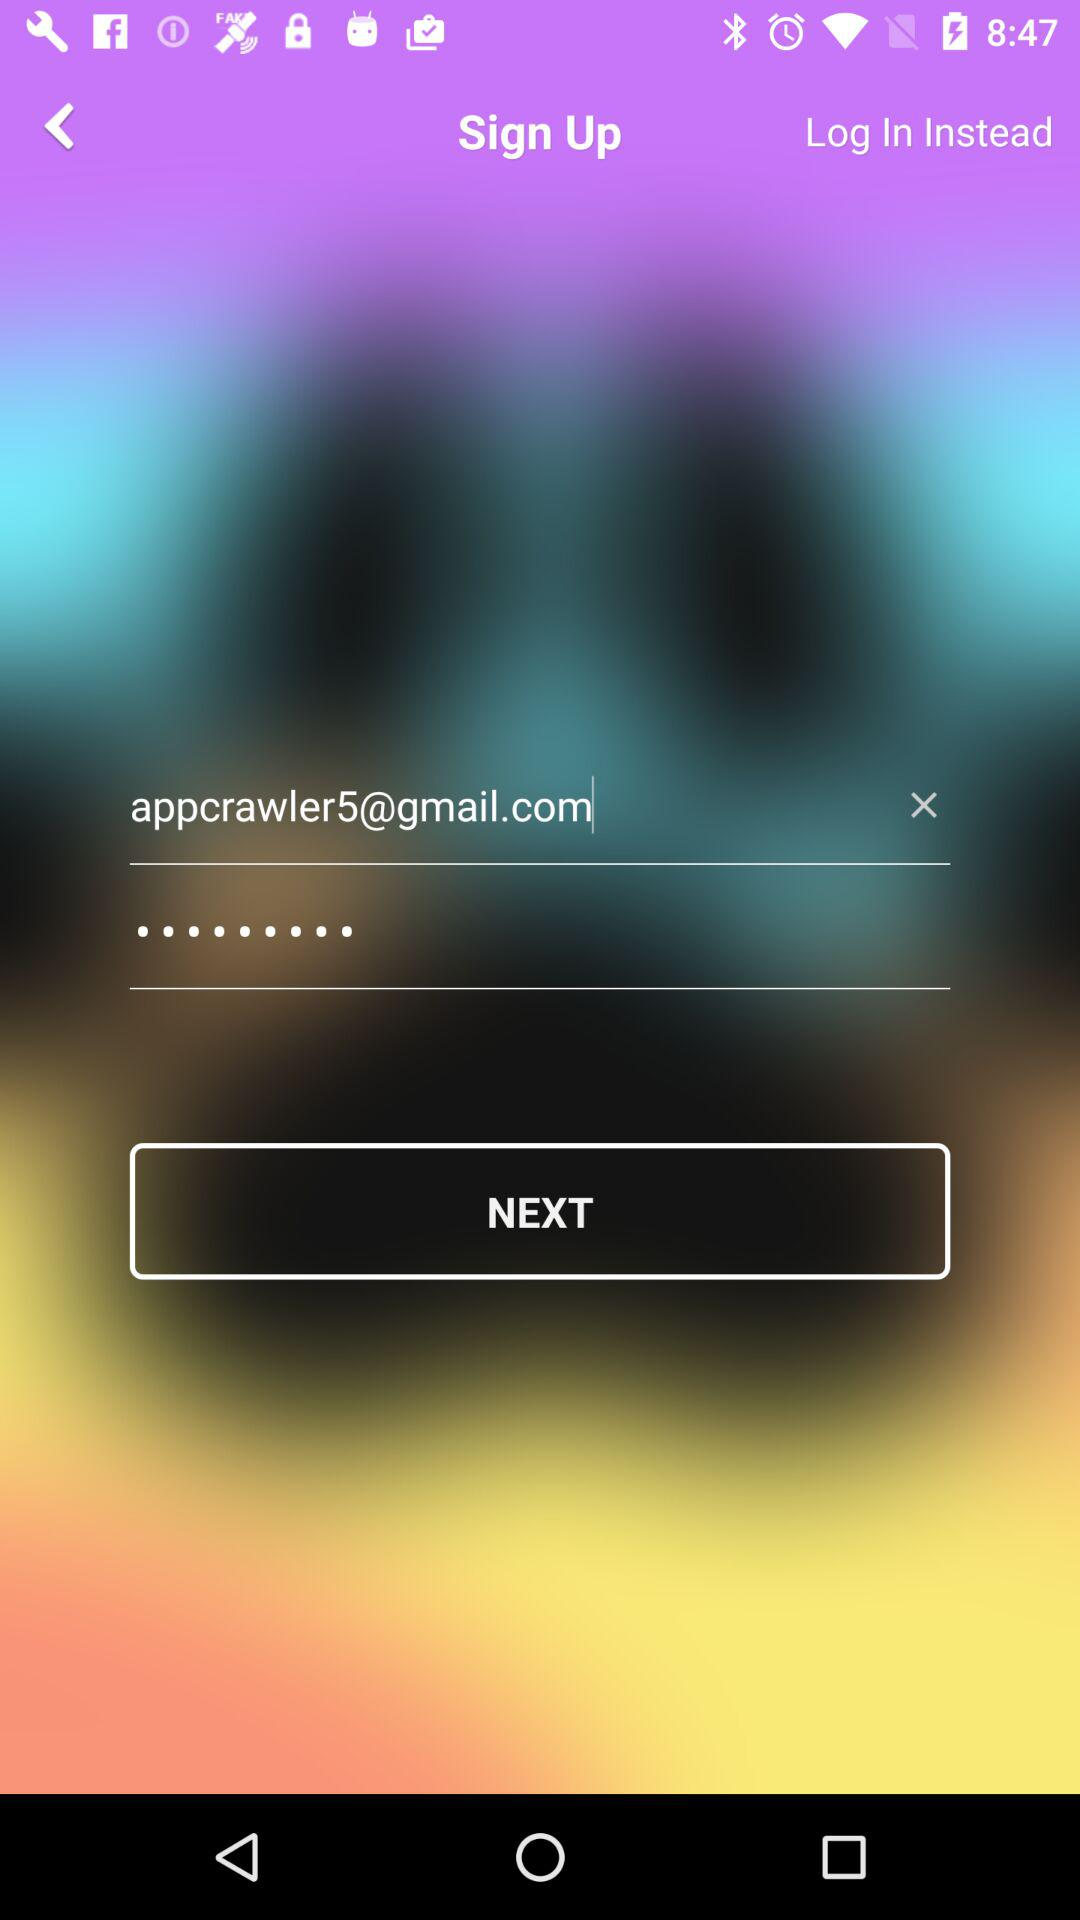How many text inputs are on the screen?
Answer the question using a single word or phrase. 2 